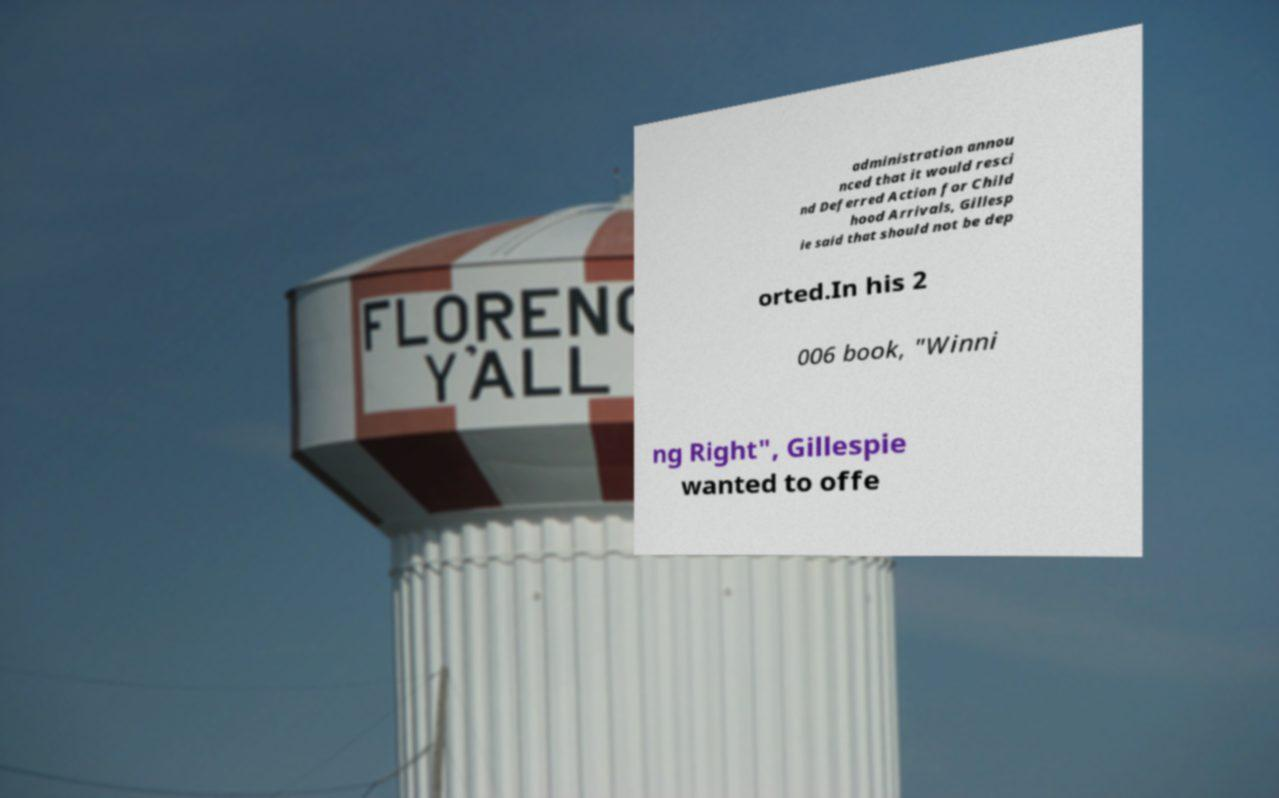Can you read and provide the text displayed in the image?This photo seems to have some interesting text. Can you extract and type it out for me? administration annou nced that it would resci nd Deferred Action for Child hood Arrivals, Gillesp ie said that should not be dep orted.In his 2 006 book, "Winni ng Right", Gillespie wanted to offe 